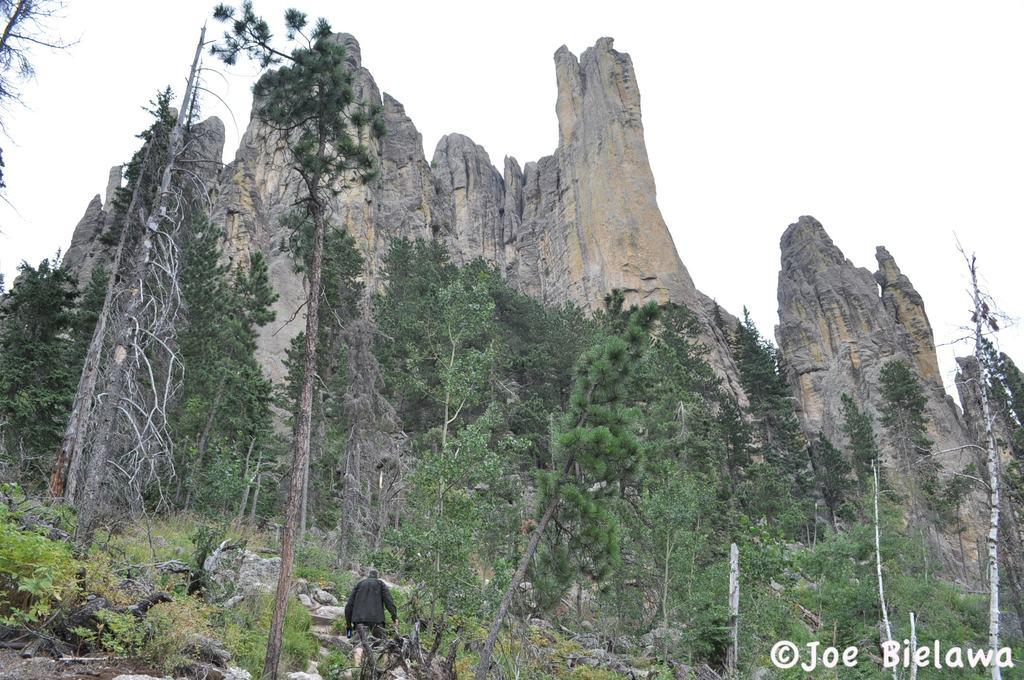What type of natural elements can be seen in the image? There are plants, trees, rocks, and mountains visible in the image. Can you describe the person in the image? There is a person in the image, but no specific details about their appearance or actions are provided. What is visible in the sky in the image? The sky is visible in the image, but no specific weather conditions or celestial bodies are mentioned. What else is present on the image besides the natural elements and the person? There is text on the image. What type of alarm is the person using in the image? There is no alarm present in the image; the person is simply standing among the natural elements. What type of neck accessory is the person wearing in the image? There is no neck accessory visible in the image; the person is not wearing any clothing or accessories. 